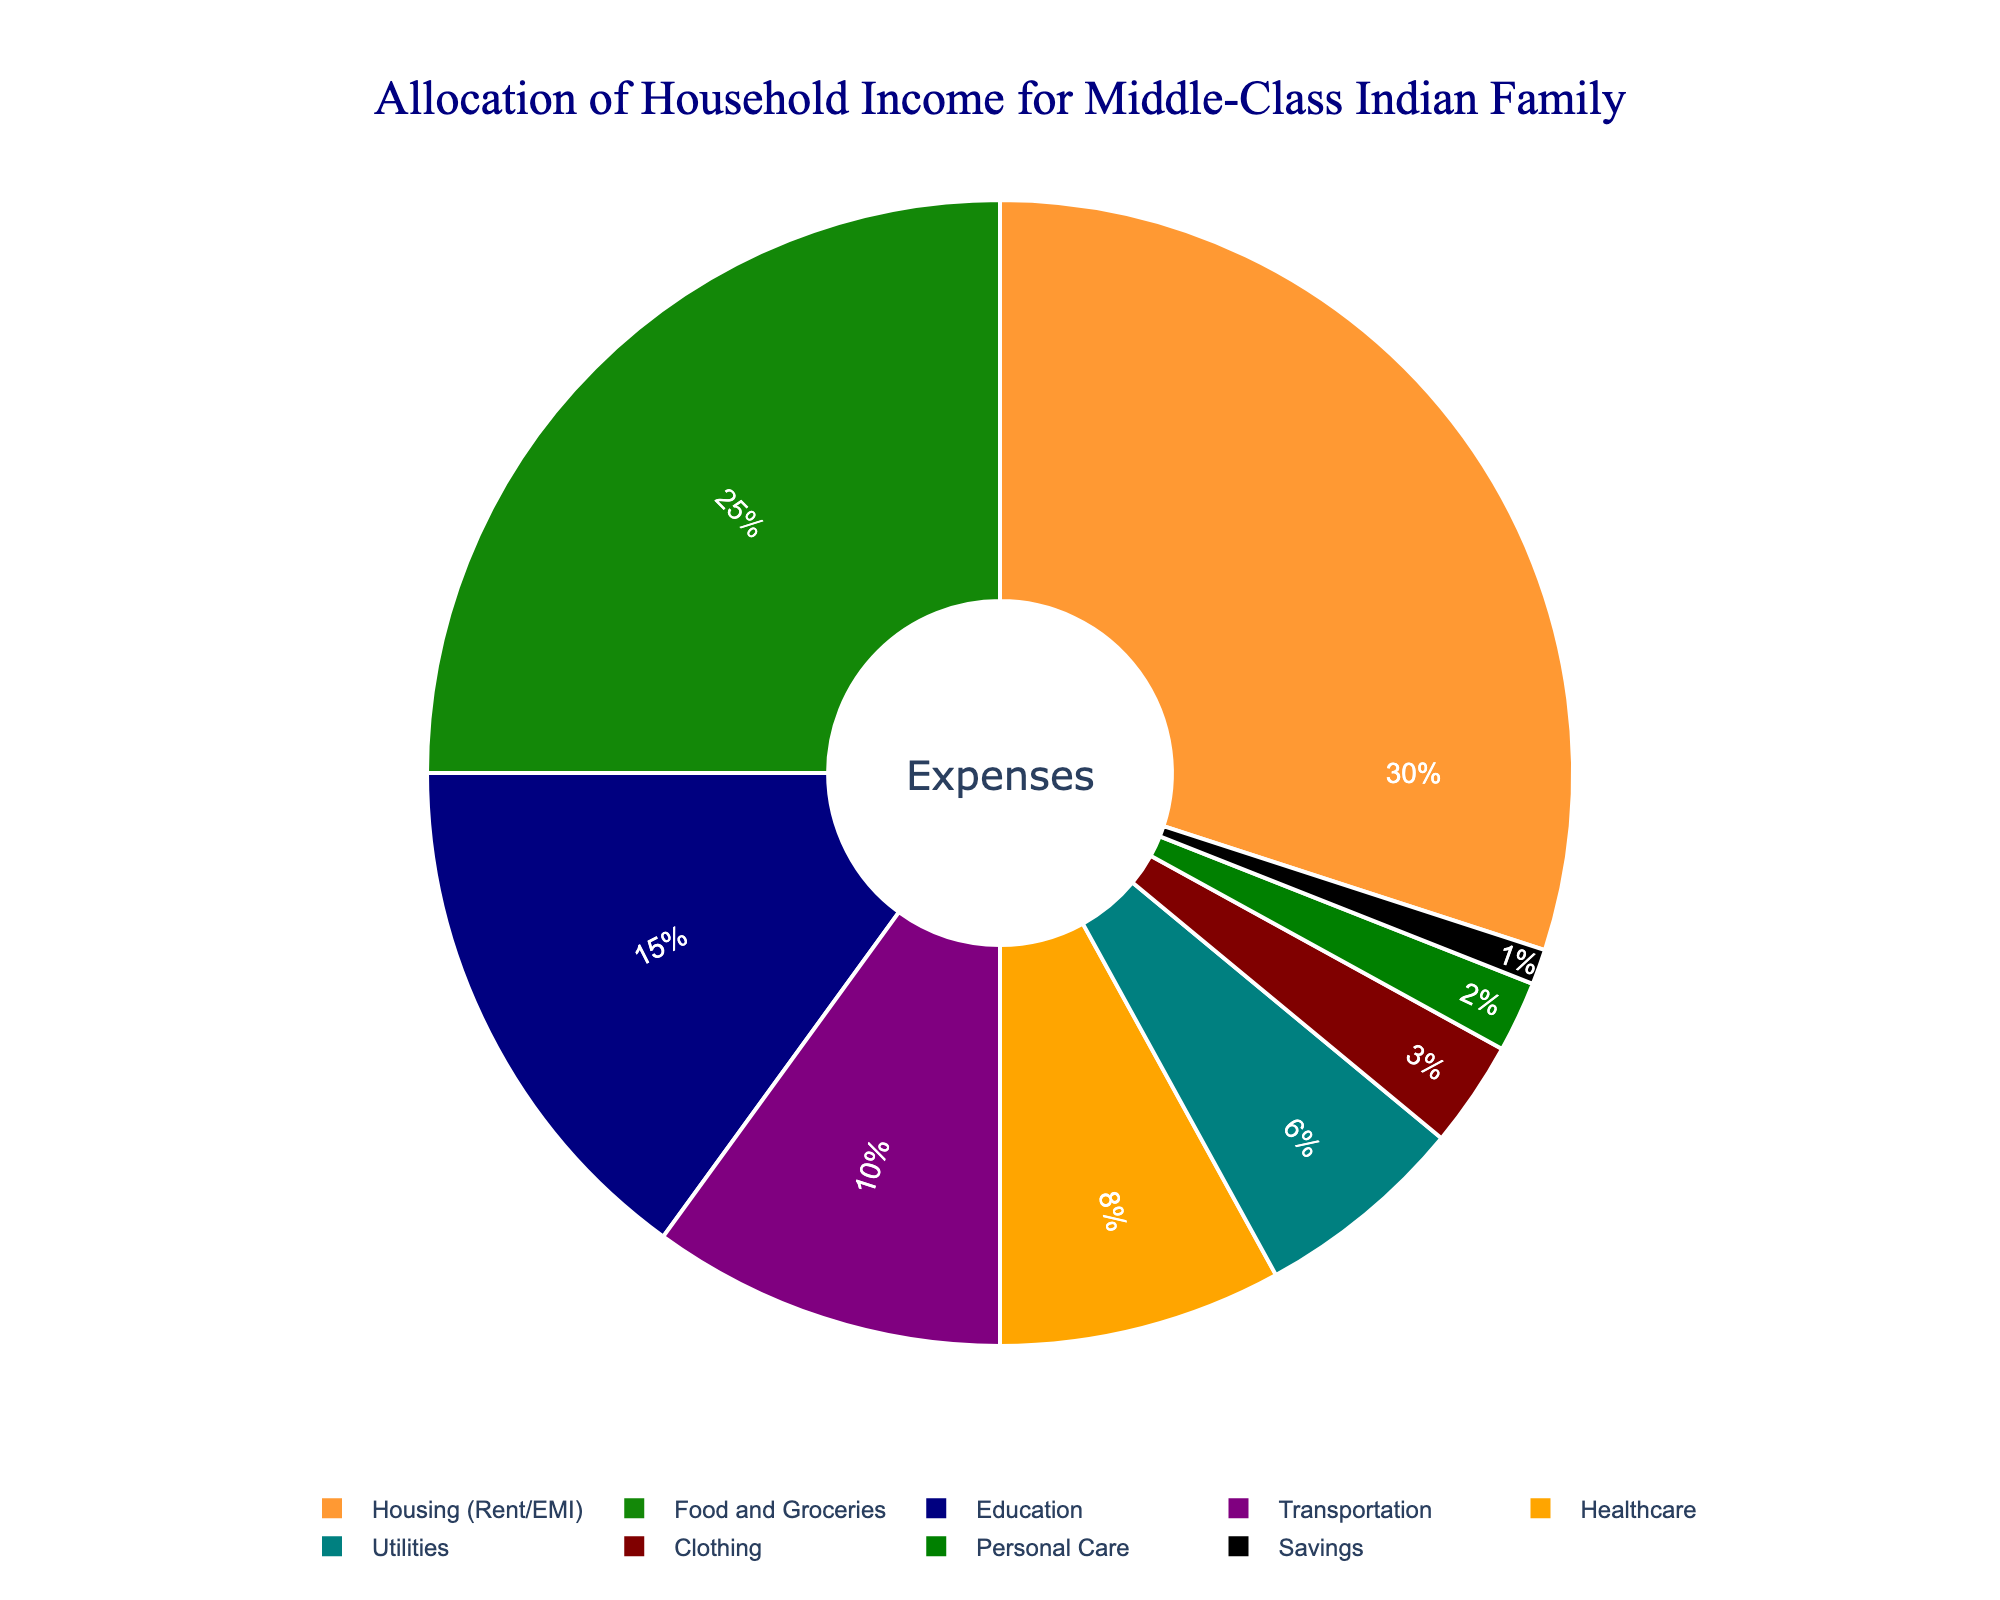What is the largest expense category for a typical middle-class Indian family? The largest expense category can be identified by looking at the pie chart segment with the largest proportion. The "Housing (Rent/EMI)" category takes up 30% of the total, making it the largest expense category.
Answer: Housing (Rent/EMI) Which category has a higher allocation, Transportation or Healthcare? To determine which category has a higher allocation, compare the percentages shown in the pie chart for both categories. Transportation is 10%, while Healthcare is 8%.
Answer: Transportation What is the total percentage allocation for Food and Groceries, Education, and Personal Care combined? Add the percentages for each of these categories: Food and Groceries (25%), Education (15%), and Personal Care (2%). The total is 25 + 15 + 2 = 42%.
Answer: 42% How much more is allocated to Housing compared to Savings? Find the difference in percentages between Housing (30%) and Savings (1%). The difference is 30 - 1 = 29%.
Answer: 29% Which category has the smallest allocation, and what is its percentage? The smallest allocation can be identified by finding the segment with the smallest proportion in the pie chart. Personal Care has the smallest allocation with 1%.
Answer: Savings, 1% What is the combined allocation for Utilities and Clothing? Add the percentages for Utilities (6%) and Clothing (3%). The combined allocation is 6 + 3 = 9%.
Answer: 9% If the total income is increased by 5%, how much would be allocated to Food and Groceries if the percentage allocation remains the same? First, calculate the total income increase. Then find the new amount for Food and Groceries by applying the percentage. If the original income is 100%, a 5% increase makes it 105%. Hence, Food and Groceries allocation would be 25% of 105%. The new allocation is 25% × 105 = 26.25%.
Answer: 26.25% How much more is spent on Education than on Clothing? Compare the percentages allocated to Education and Clothing. Education is 15%, and Clothing is 3%. The difference is 15 - 3 = 12%.
Answer: 12% What is the difference in allocation between Food and Groceries and Healthcare? Compare the percentages for Food and Groceries (25%) and Healthcare (8%). The difference is 25 - 8 = 17%.
Answer: 17% Which category accounts for more of the budget, Utilities or Education? Compare the percentages for Utilities (6%) and Education (15%). Education has a higher allocation.
Answer: Education 